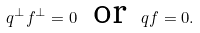<formula> <loc_0><loc_0><loc_500><loc_500>q ^ { \perp } f ^ { \perp } = 0 \text { \ or \ } q f = 0 .</formula> 